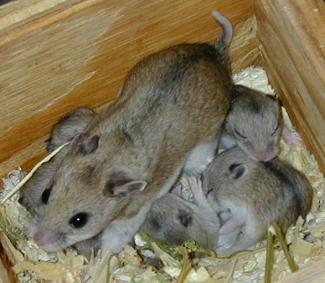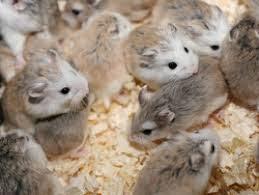The first image is the image on the left, the second image is the image on the right. Given the left and right images, does the statement "A rodent's face is seen through a hole in one image." hold true? Answer yes or no. No. The first image is the image on the left, the second image is the image on the right. Analyze the images presented: Is the assertion "More than five rodents are positioned in the woodchips and mulch." valid? Answer yes or no. Yes. 